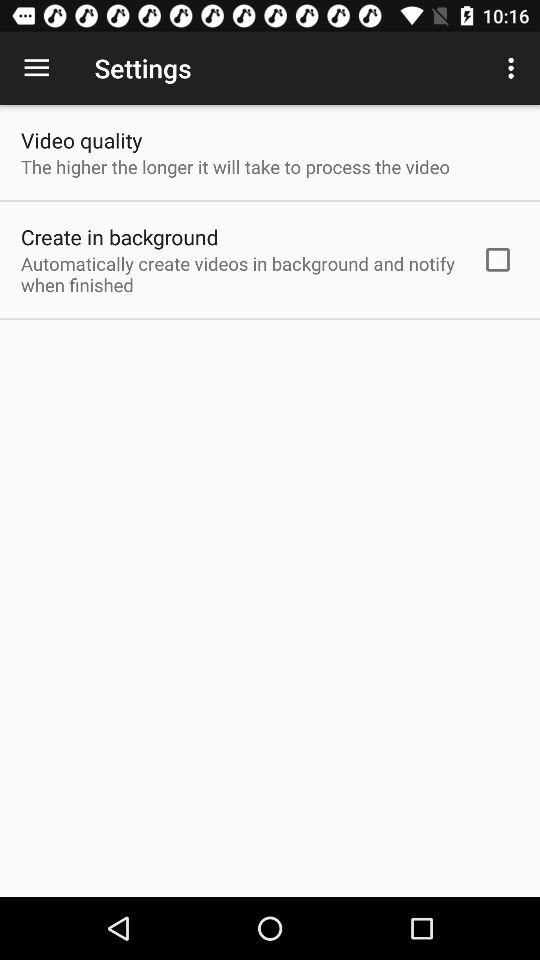What is the current status of the "Create in background" setting? The status is "off". 